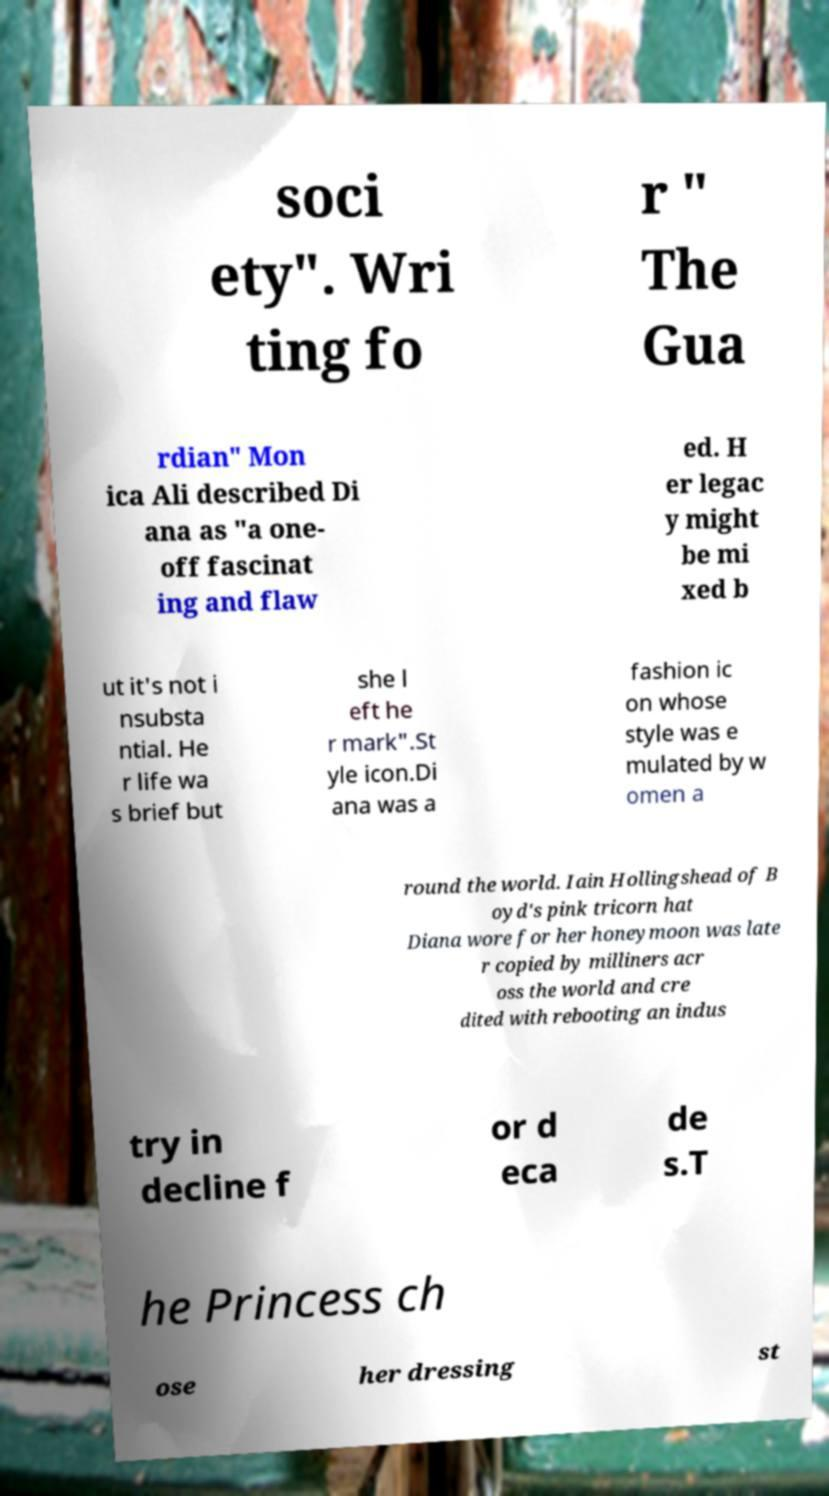For documentation purposes, I need the text within this image transcribed. Could you provide that? soci ety". Wri ting fo r " The Gua rdian" Mon ica Ali described Di ana as "a one- off fascinat ing and flaw ed. H er legac y might be mi xed b ut it's not i nsubsta ntial. He r life wa s brief but she l eft he r mark".St yle icon.Di ana was a fashion ic on whose style was e mulated by w omen a round the world. Iain Hollingshead of B oyd's pink tricorn hat Diana wore for her honeymoon was late r copied by milliners acr oss the world and cre dited with rebooting an indus try in decline f or d eca de s.T he Princess ch ose her dressing st 